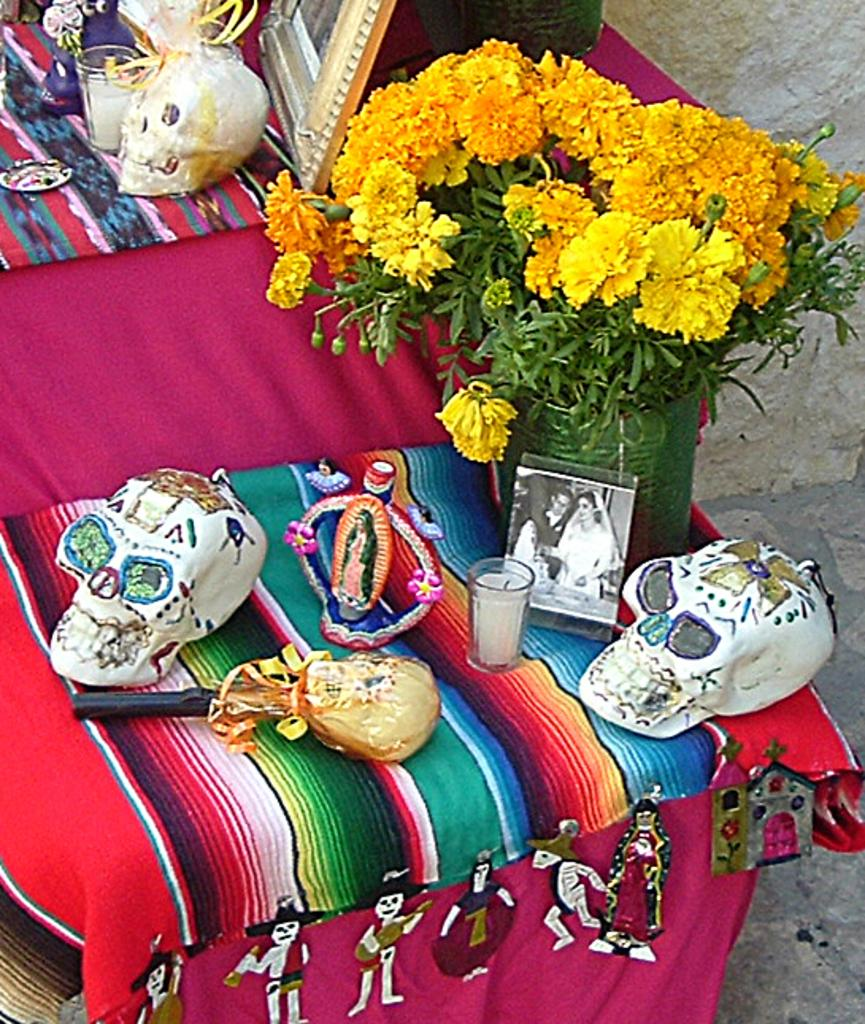What objects are present in the image that are related to death or mortality? There are two white color skulls in the image. What else can be seen in the image besides the skulls? There is a photo and a green color plant in the image. Are there any flowers visible in the image? Yes, there are yellow color flowers in the image. Can you tell me who the expert is in the image? There is no expert present in the image. What type of vein can be seen in the image? There are no veins visible in the image. 